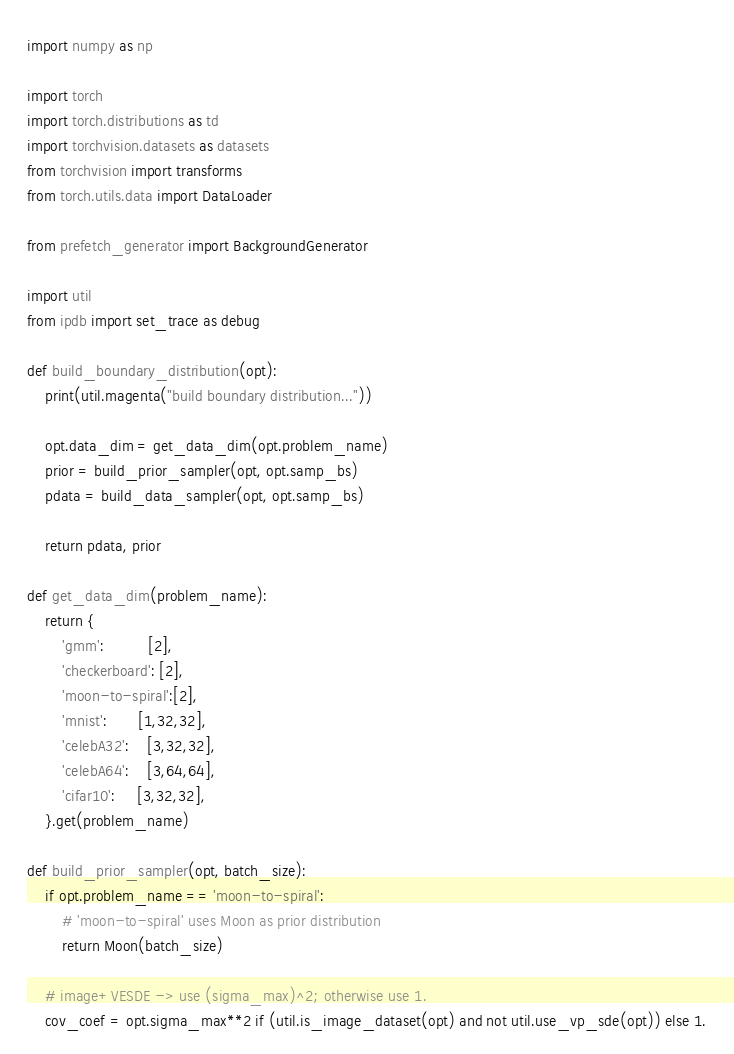<code> <loc_0><loc_0><loc_500><loc_500><_Python_>import numpy as np

import torch
import torch.distributions as td
import torchvision.datasets as datasets
from torchvision import transforms
from torch.utils.data import DataLoader

from prefetch_generator import BackgroundGenerator

import util
from ipdb import set_trace as debug

def build_boundary_distribution(opt):
    print(util.magenta("build boundary distribution..."))

    opt.data_dim = get_data_dim(opt.problem_name)
    prior = build_prior_sampler(opt, opt.samp_bs)
    pdata = build_data_sampler(opt, opt.samp_bs)

    return pdata, prior

def get_data_dim(problem_name):
    return {
        'gmm':          [2],
        'checkerboard': [2],
        'moon-to-spiral':[2],
        'mnist':       [1,32,32],
        'celebA32':    [3,32,32],
        'celebA64':    [3,64,64],
        'cifar10':     [3,32,32],
    }.get(problem_name)

def build_prior_sampler(opt, batch_size):
    if opt.problem_name == 'moon-to-spiral':
        # 'moon-to-spiral' uses Moon as prior distribution
        return Moon(batch_size)

    # image+VESDE -> use (sigma_max)^2; otherwise use 1.
    cov_coef = opt.sigma_max**2 if (util.is_image_dataset(opt) and not util.use_vp_sde(opt)) else 1.</code> 